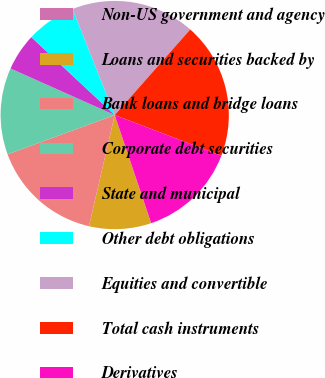<chart> <loc_0><loc_0><loc_500><loc_500><pie_chart><fcel>Non-US government and agency<fcel>Loans and securities backed by<fcel>Bank loans and bridge loans<fcel>Corporate debt securities<fcel>State and municipal<fcel>Other debt obligations<fcel>Equities and convertible<fcel>Total cash instruments<fcel>Derivatives<nl><fcel>0.02%<fcel>8.78%<fcel>15.78%<fcel>12.28%<fcel>5.27%<fcel>7.02%<fcel>17.53%<fcel>19.29%<fcel>14.03%<nl></chart> 